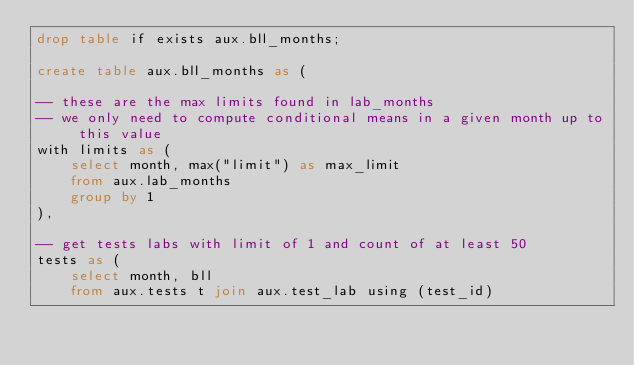<code> <loc_0><loc_0><loc_500><loc_500><_SQL_>drop table if exists aux.bll_months;

create table aux.bll_months as (

-- these are the max limits found in lab_months
-- we only need to compute conditional means in a given month up to this value
with limits as (
    select month, max("limit") as max_limit
    from aux.lab_months
    group by 1
),

-- get tests labs with limit of 1 and count of at least 50
tests as (
    select month, bll
    from aux.tests t join aux.test_lab using (test_id)</code> 